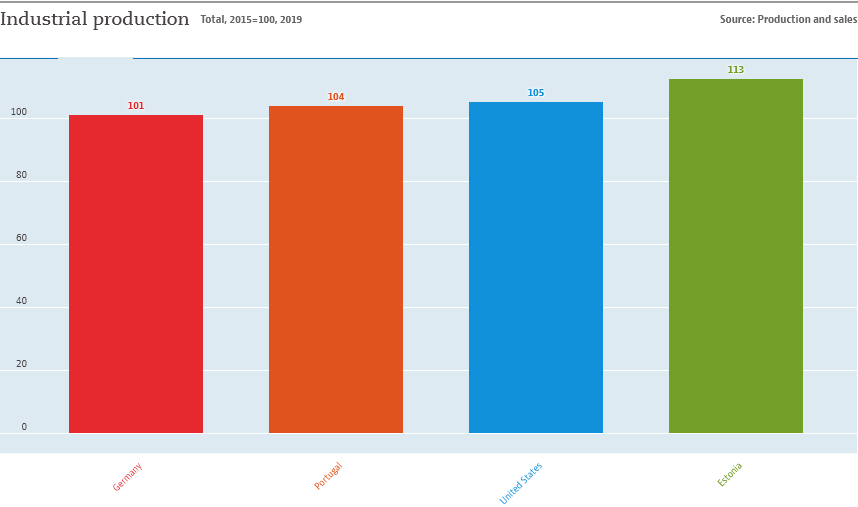Indicate a few pertinent items in this graphic. There are countries that have a value greater than 105. The country represented by the green bar is Estonia. 